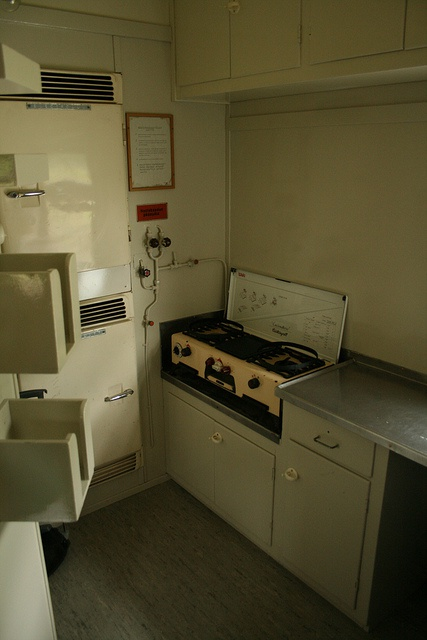Describe the objects in this image and their specific colors. I can see refrigerator in darkgreen, tan, and olive tones and oven in darkgreen, olive, and black tones in this image. 